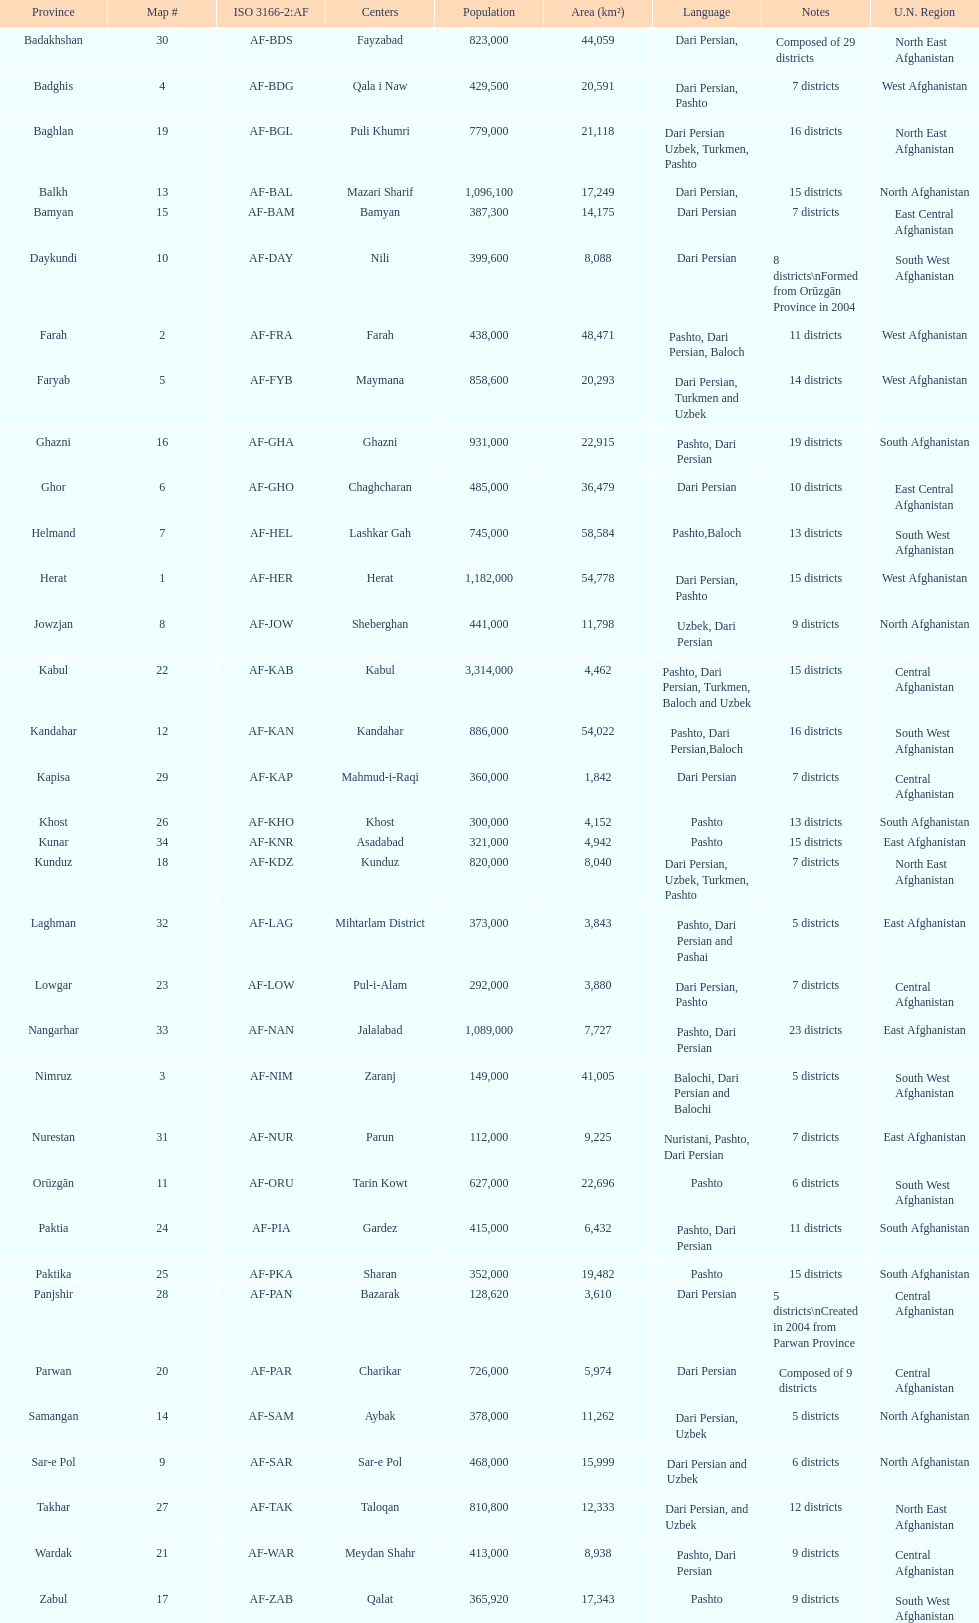What is the number of districts in the kunduz province? 7. 